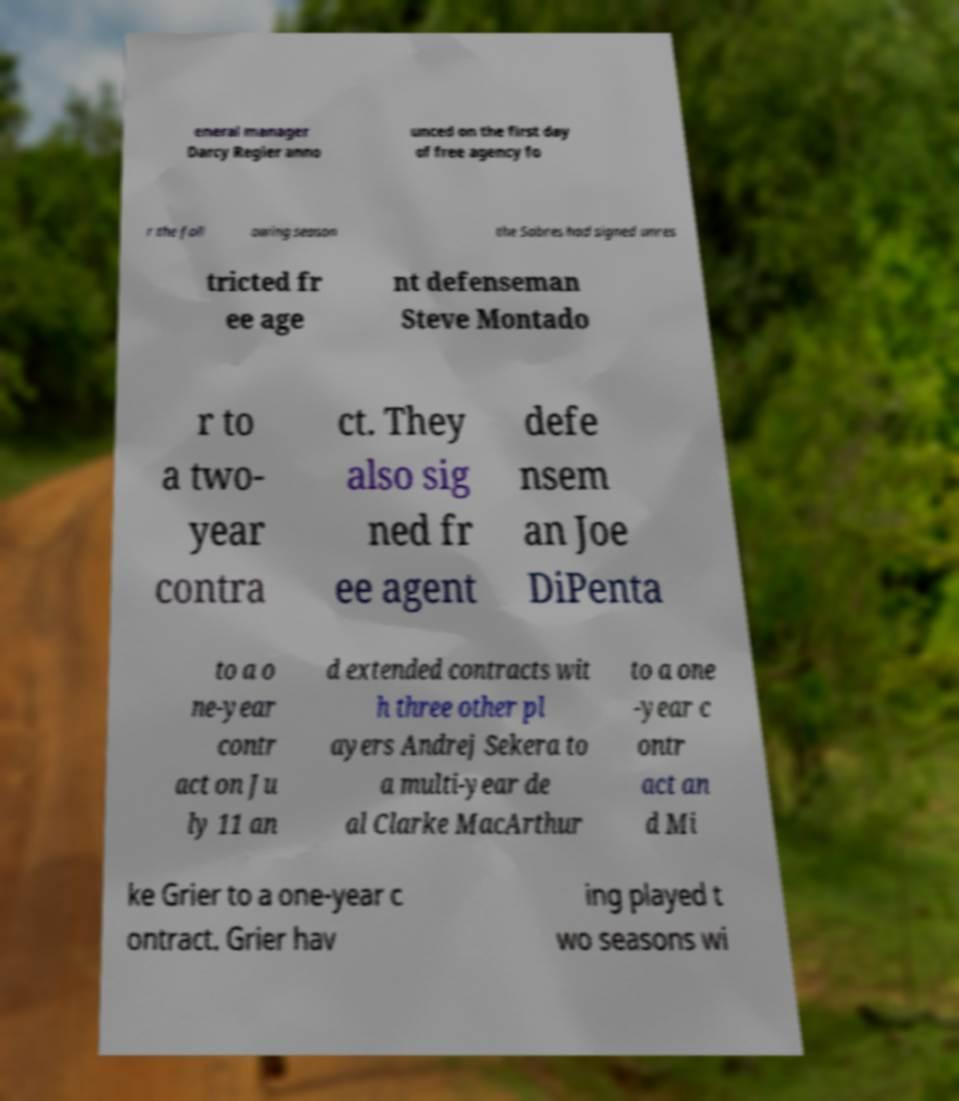Can you read and provide the text displayed in the image?This photo seems to have some interesting text. Can you extract and type it out for me? eneral manager Darcy Regier anno unced on the first day of free agency fo r the foll owing season the Sabres had signed unres tricted fr ee age nt defenseman Steve Montado r to a two- year contra ct. They also sig ned fr ee agent defe nsem an Joe DiPenta to a o ne-year contr act on Ju ly 11 an d extended contracts wit h three other pl ayers Andrej Sekera to a multi-year de al Clarke MacArthur to a one -year c ontr act an d Mi ke Grier to a one-year c ontract. Grier hav ing played t wo seasons wi 